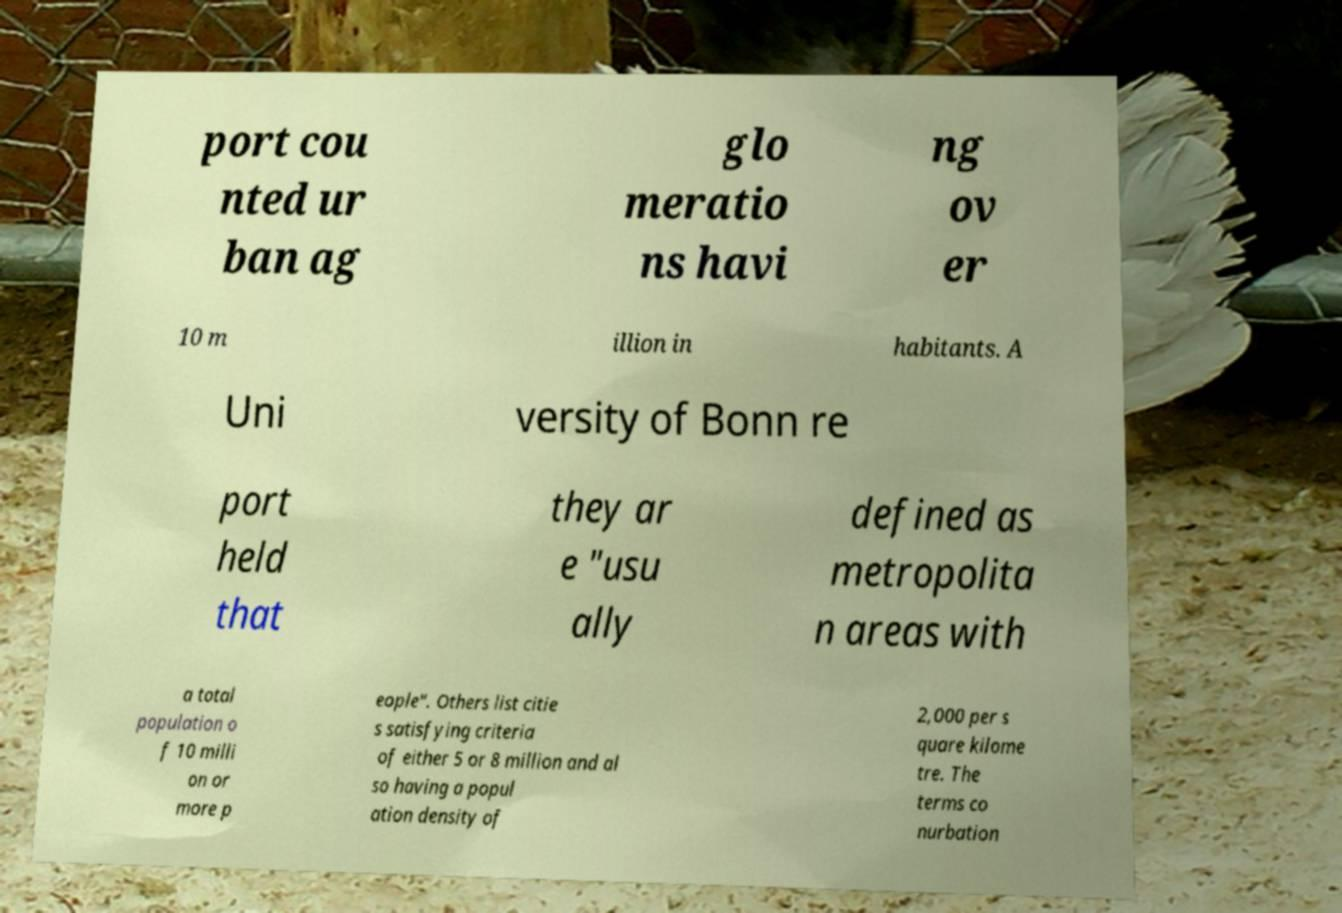I need the written content from this picture converted into text. Can you do that? port cou nted ur ban ag glo meratio ns havi ng ov er 10 m illion in habitants. A Uni versity of Bonn re port held that they ar e "usu ally defined as metropolita n areas with a total population o f 10 milli on or more p eople". Others list citie s satisfying criteria of either 5 or 8 million and al so having a popul ation density of 2,000 per s quare kilome tre. The terms co nurbation 